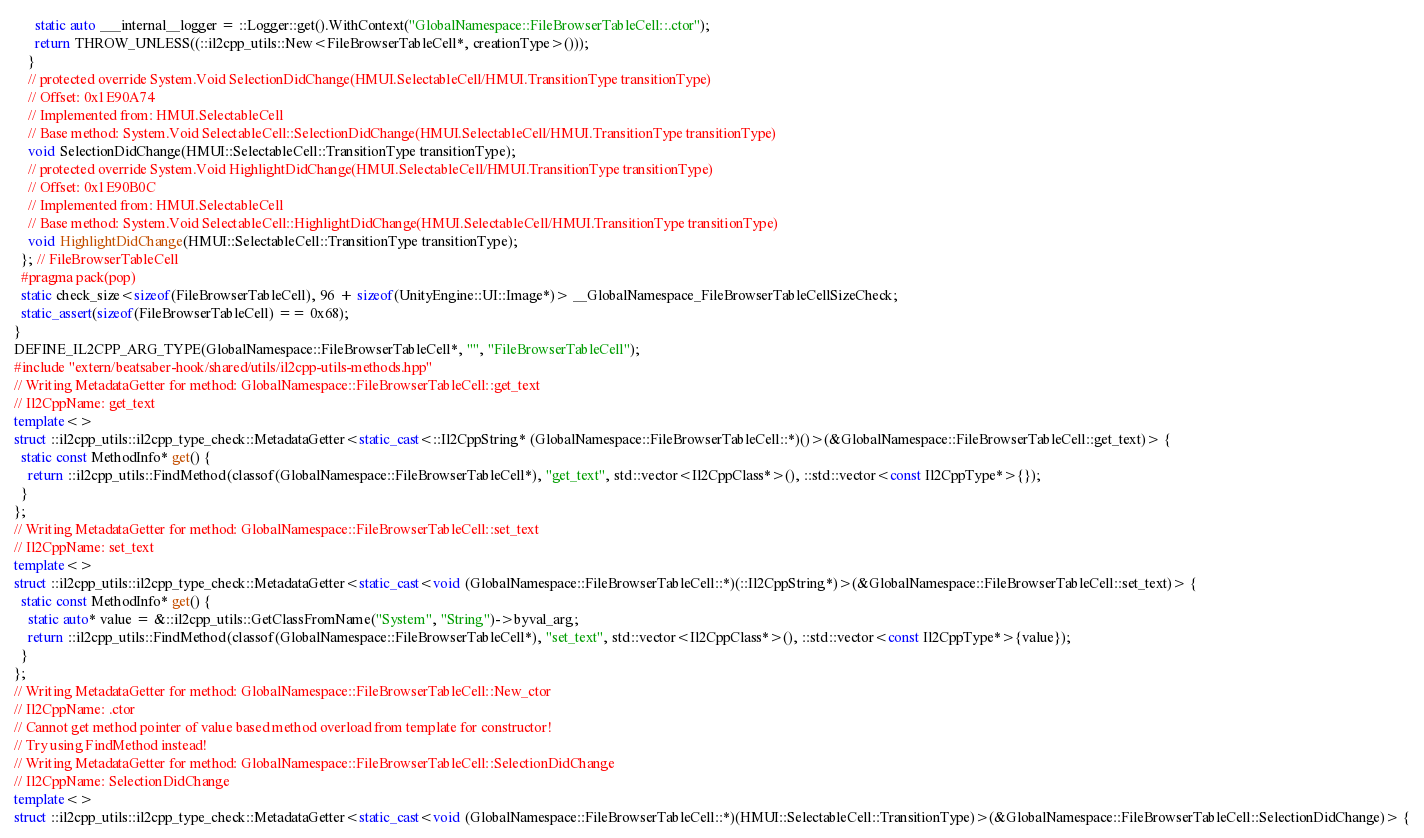Convert code to text. <code><loc_0><loc_0><loc_500><loc_500><_C++_>      static auto ___internal__logger = ::Logger::get().WithContext("GlobalNamespace::FileBrowserTableCell::.ctor");
      return THROW_UNLESS((::il2cpp_utils::New<FileBrowserTableCell*, creationType>()));
    }
    // protected override System.Void SelectionDidChange(HMUI.SelectableCell/HMUI.TransitionType transitionType)
    // Offset: 0x1E90A74
    // Implemented from: HMUI.SelectableCell
    // Base method: System.Void SelectableCell::SelectionDidChange(HMUI.SelectableCell/HMUI.TransitionType transitionType)
    void SelectionDidChange(HMUI::SelectableCell::TransitionType transitionType);
    // protected override System.Void HighlightDidChange(HMUI.SelectableCell/HMUI.TransitionType transitionType)
    // Offset: 0x1E90B0C
    // Implemented from: HMUI.SelectableCell
    // Base method: System.Void SelectableCell::HighlightDidChange(HMUI.SelectableCell/HMUI.TransitionType transitionType)
    void HighlightDidChange(HMUI::SelectableCell::TransitionType transitionType);
  }; // FileBrowserTableCell
  #pragma pack(pop)
  static check_size<sizeof(FileBrowserTableCell), 96 + sizeof(UnityEngine::UI::Image*)> __GlobalNamespace_FileBrowserTableCellSizeCheck;
  static_assert(sizeof(FileBrowserTableCell) == 0x68);
}
DEFINE_IL2CPP_ARG_TYPE(GlobalNamespace::FileBrowserTableCell*, "", "FileBrowserTableCell");
#include "extern/beatsaber-hook/shared/utils/il2cpp-utils-methods.hpp"
// Writing MetadataGetter for method: GlobalNamespace::FileBrowserTableCell::get_text
// Il2CppName: get_text
template<>
struct ::il2cpp_utils::il2cpp_type_check::MetadataGetter<static_cast<::Il2CppString* (GlobalNamespace::FileBrowserTableCell::*)()>(&GlobalNamespace::FileBrowserTableCell::get_text)> {
  static const MethodInfo* get() {
    return ::il2cpp_utils::FindMethod(classof(GlobalNamespace::FileBrowserTableCell*), "get_text", std::vector<Il2CppClass*>(), ::std::vector<const Il2CppType*>{});
  }
};
// Writing MetadataGetter for method: GlobalNamespace::FileBrowserTableCell::set_text
// Il2CppName: set_text
template<>
struct ::il2cpp_utils::il2cpp_type_check::MetadataGetter<static_cast<void (GlobalNamespace::FileBrowserTableCell::*)(::Il2CppString*)>(&GlobalNamespace::FileBrowserTableCell::set_text)> {
  static const MethodInfo* get() {
    static auto* value = &::il2cpp_utils::GetClassFromName("System", "String")->byval_arg;
    return ::il2cpp_utils::FindMethod(classof(GlobalNamespace::FileBrowserTableCell*), "set_text", std::vector<Il2CppClass*>(), ::std::vector<const Il2CppType*>{value});
  }
};
// Writing MetadataGetter for method: GlobalNamespace::FileBrowserTableCell::New_ctor
// Il2CppName: .ctor
// Cannot get method pointer of value based method overload from template for constructor!
// Try using FindMethod instead!
// Writing MetadataGetter for method: GlobalNamespace::FileBrowserTableCell::SelectionDidChange
// Il2CppName: SelectionDidChange
template<>
struct ::il2cpp_utils::il2cpp_type_check::MetadataGetter<static_cast<void (GlobalNamespace::FileBrowserTableCell::*)(HMUI::SelectableCell::TransitionType)>(&GlobalNamespace::FileBrowserTableCell::SelectionDidChange)> {</code> 